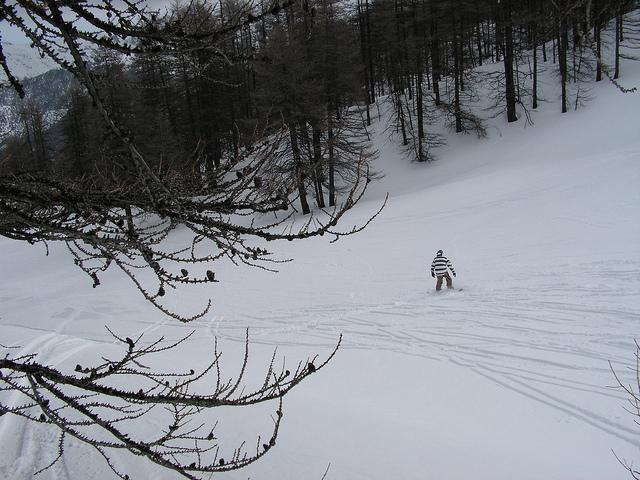What are the little bumps on the tree branches? fruits 